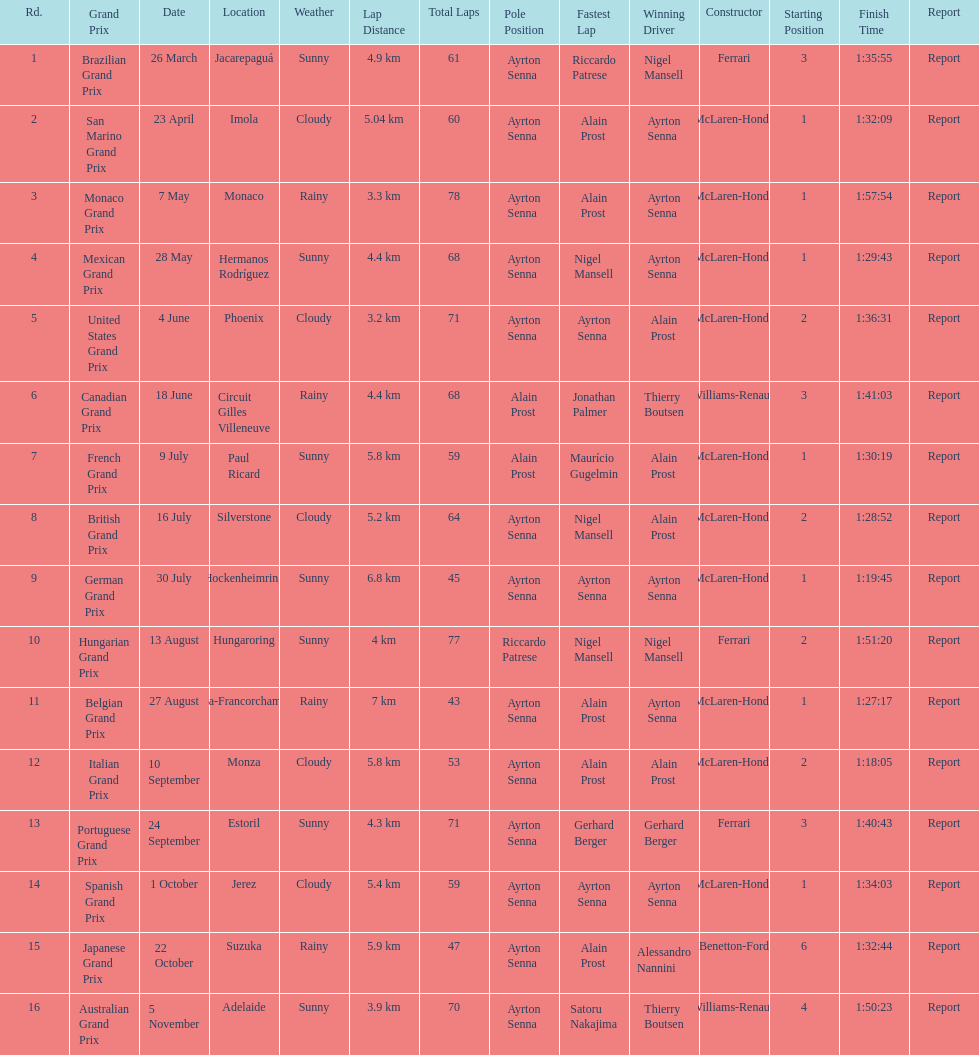How many did alain prost have the fastest lap? 5. 